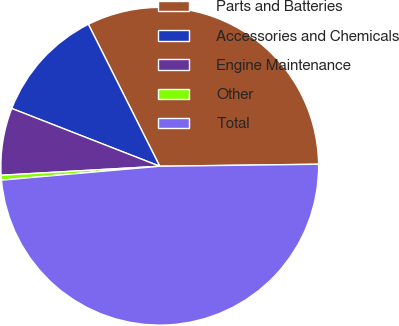Convert chart to OTSL. <chart><loc_0><loc_0><loc_500><loc_500><pie_chart><fcel>Parts and Batteries<fcel>Accessories and Chemicals<fcel>Engine Maintenance<fcel>Other<fcel>Total<nl><fcel>32.21%<fcel>11.66%<fcel>6.83%<fcel>0.49%<fcel>48.8%<nl></chart> 